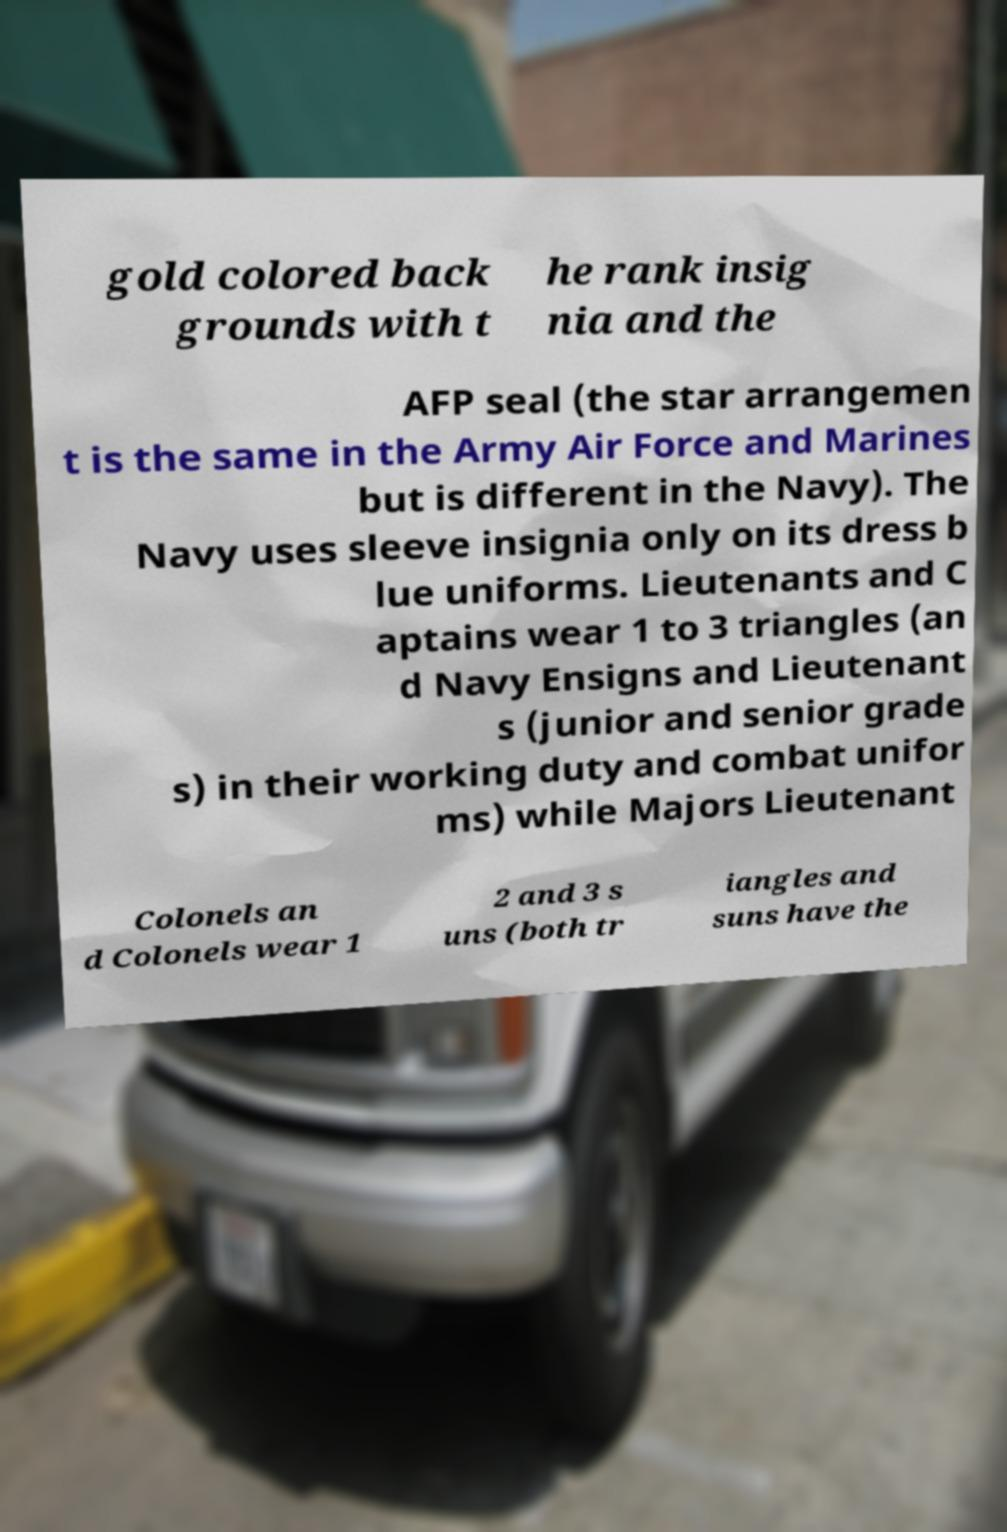Please identify and transcribe the text found in this image. gold colored back grounds with t he rank insig nia and the AFP seal (the star arrangemen t is the same in the Army Air Force and Marines but is different in the Navy). The Navy uses sleeve insignia only on its dress b lue uniforms. Lieutenants and C aptains wear 1 to 3 triangles (an d Navy Ensigns and Lieutenant s (junior and senior grade s) in their working duty and combat unifor ms) while Majors Lieutenant Colonels an d Colonels wear 1 2 and 3 s uns (both tr iangles and suns have the 